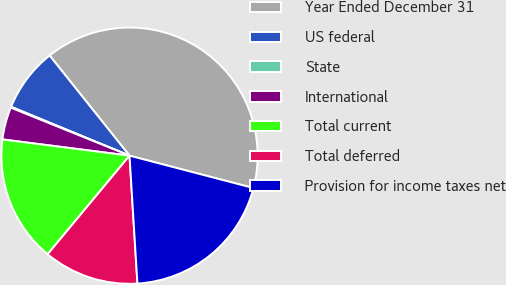Convert chart to OTSL. <chart><loc_0><loc_0><loc_500><loc_500><pie_chart><fcel>Year Ended December 31<fcel>US federal<fcel>State<fcel>International<fcel>Total current<fcel>Total deferred<fcel>Provision for income taxes net<nl><fcel>39.79%<fcel>8.05%<fcel>0.12%<fcel>4.09%<fcel>15.99%<fcel>12.02%<fcel>19.95%<nl></chart> 